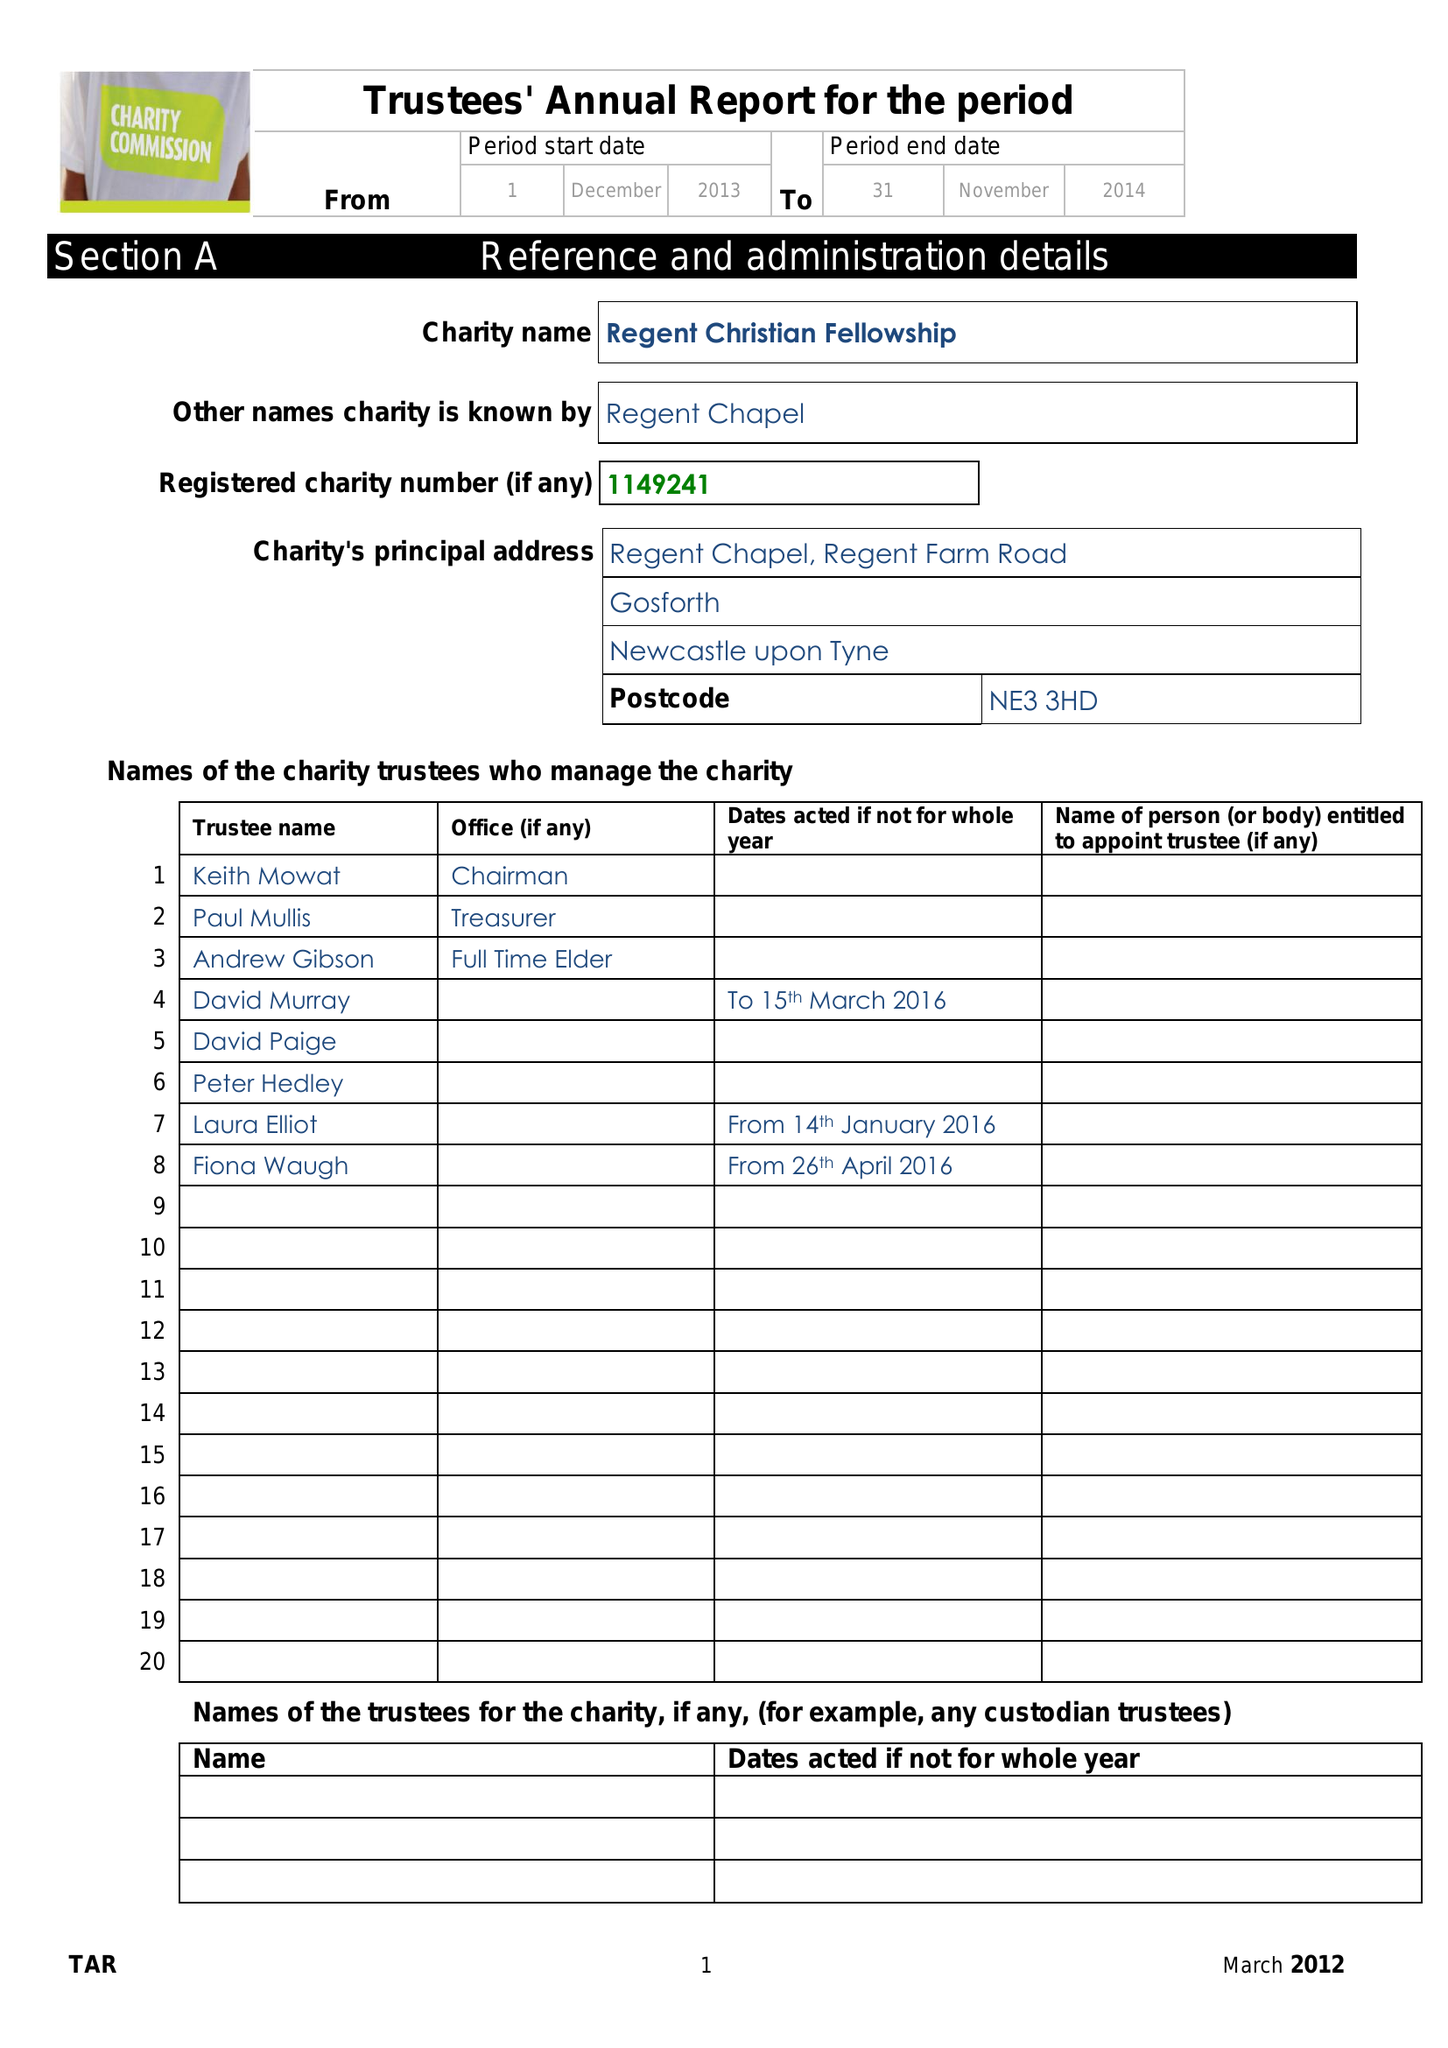What is the value for the address__postcode?
Answer the question using a single word or phrase. NE3 3HD 